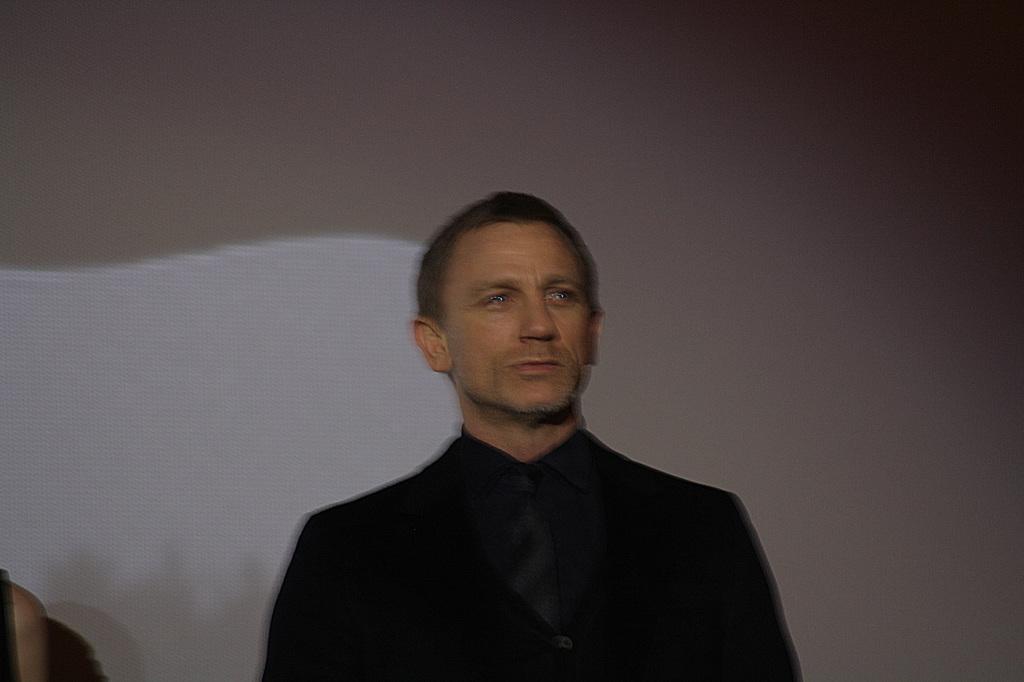Please provide a concise description of this image. There is a man standing. In the background we can see wall and person hand. 